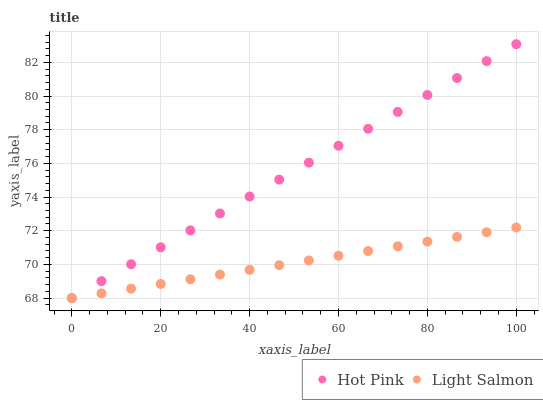Does Light Salmon have the minimum area under the curve?
Answer yes or no. Yes. Does Hot Pink have the maximum area under the curve?
Answer yes or no. Yes. Does Hot Pink have the minimum area under the curve?
Answer yes or no. No. Is Hot Pink the smoothest?
Answer yes or no. Yes. Is Light Salmon the roughest?
Answer yes or no. Yes. Is Hot Pink the roughest?
Answer yes or no. No. Does Light Salmon have the lowest value?
Answer yes or no. Yes. Does Hot Pink have the highest value?
Answer yes or no. Yes. Does Hot Pink intersect Light Salmon?
Answer yes or no. Yes. Is Hot Pink less than Light Salmon?
Answer yes or no. No. Is Hot Pink greater than Light Salmon?
Answer yes or no. No. 